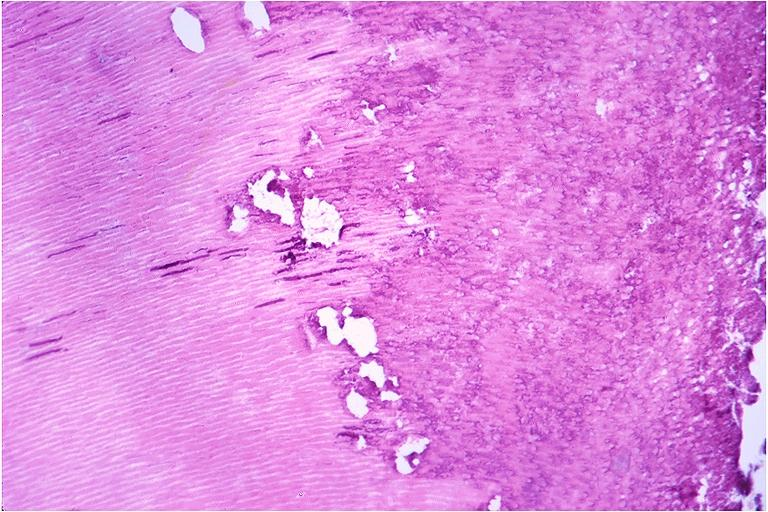s oral present?
Answer the question using a single word or phrase. Yes 